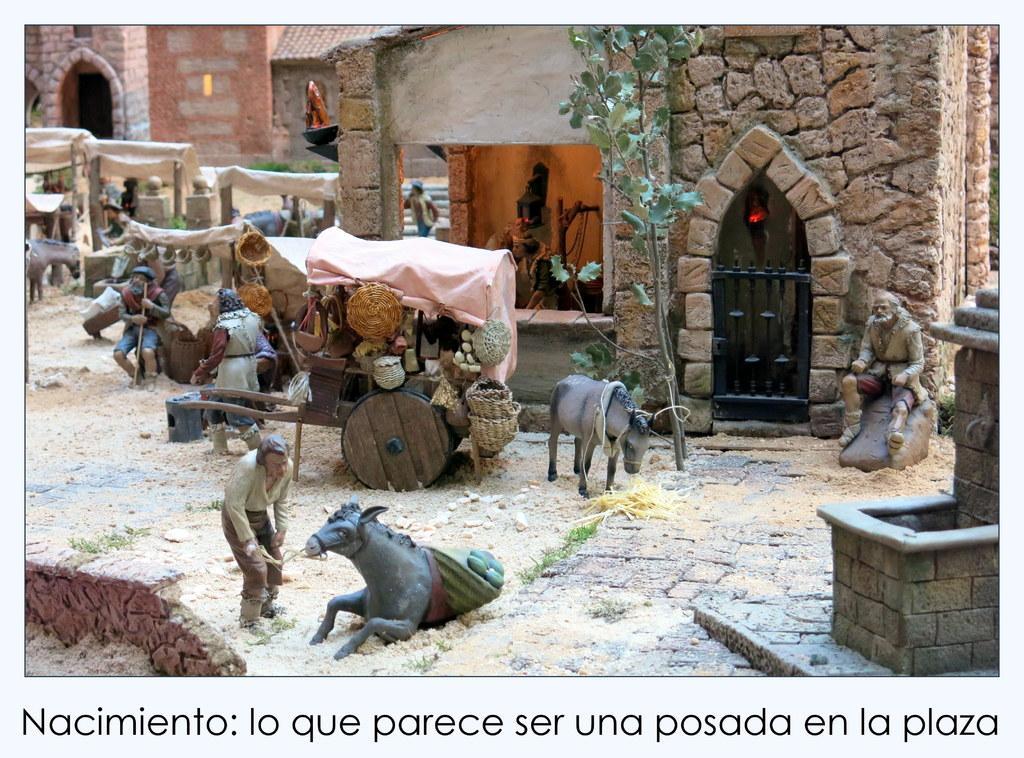Describe this image in one or two sentences. In this picture I can see sculptures of persons and animals vehicle and building and trees tents visible in the middle and at the bottom I can see there is a text. 